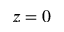<formula> <loc_0><loc_0><loc_500><loc_500>z = 0</formula> 